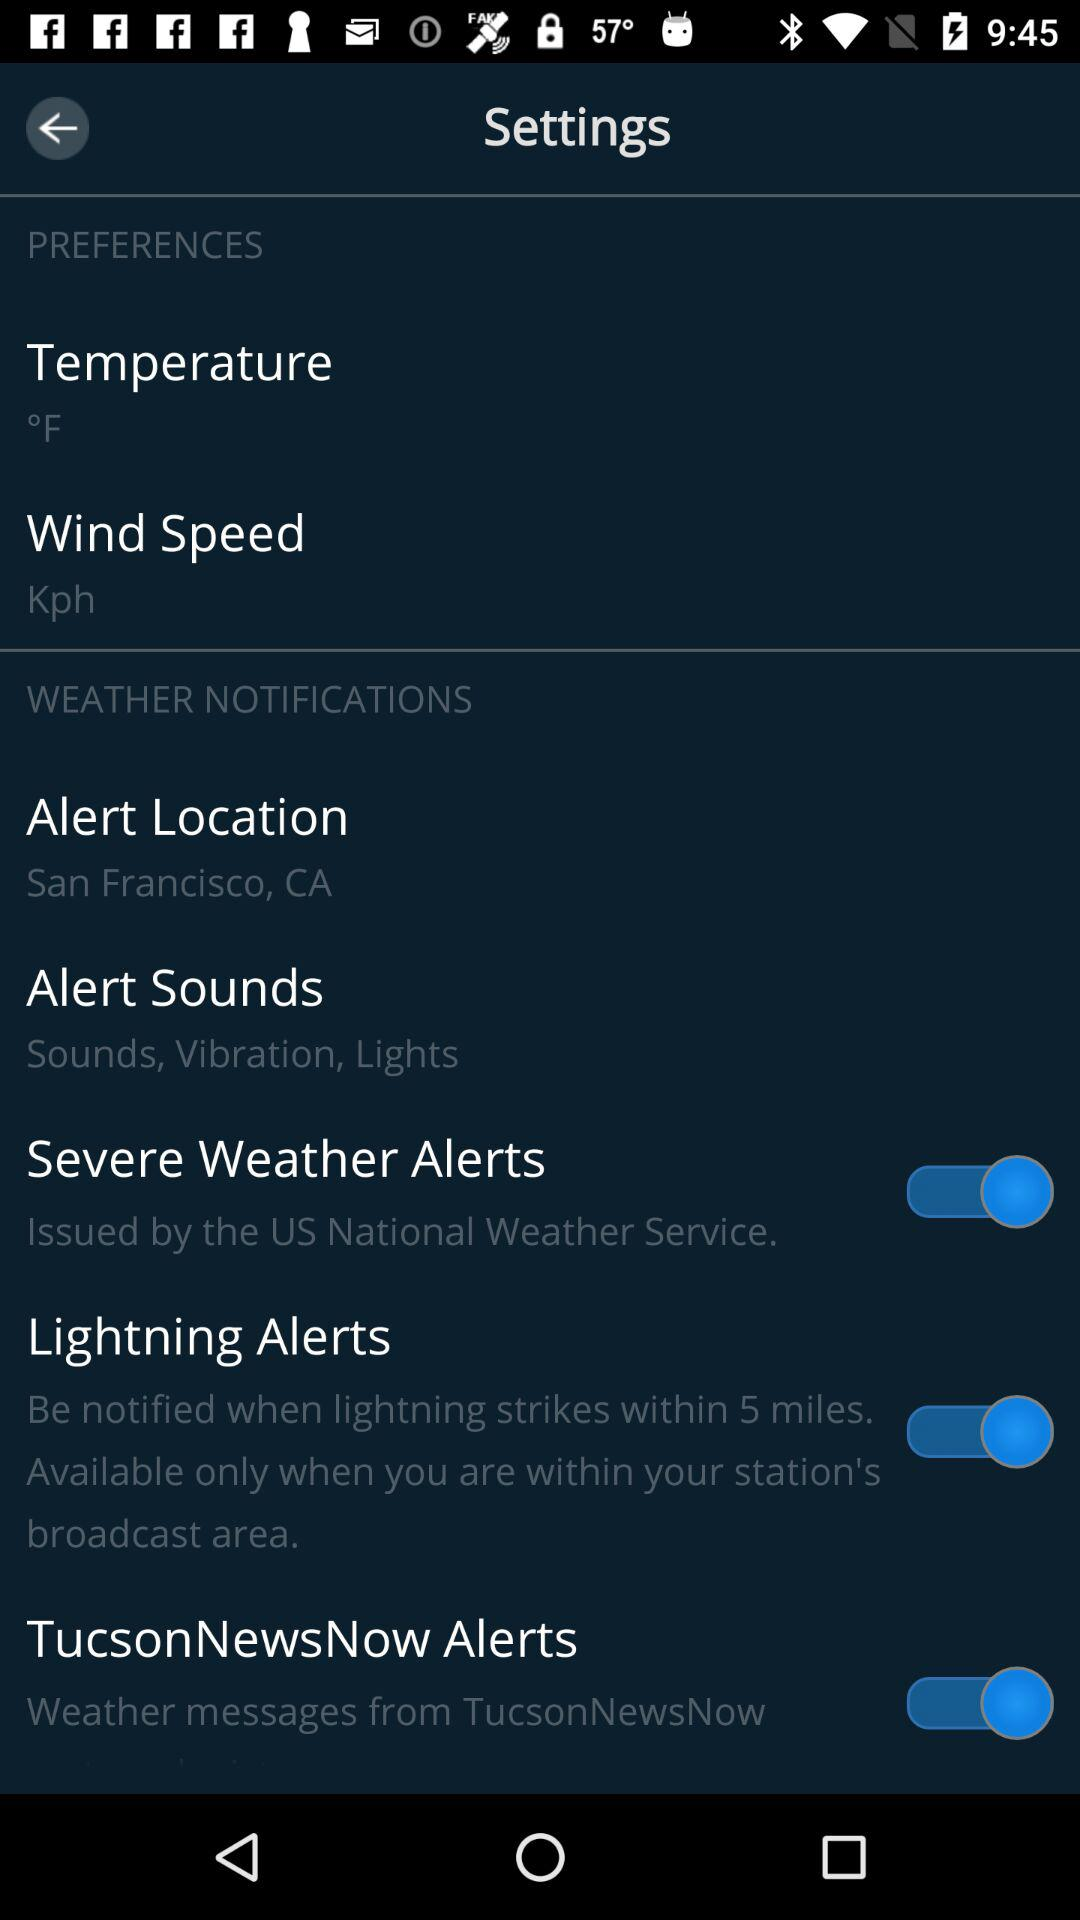What is the selected unit for measuring temperature? The selected unit is °F. 